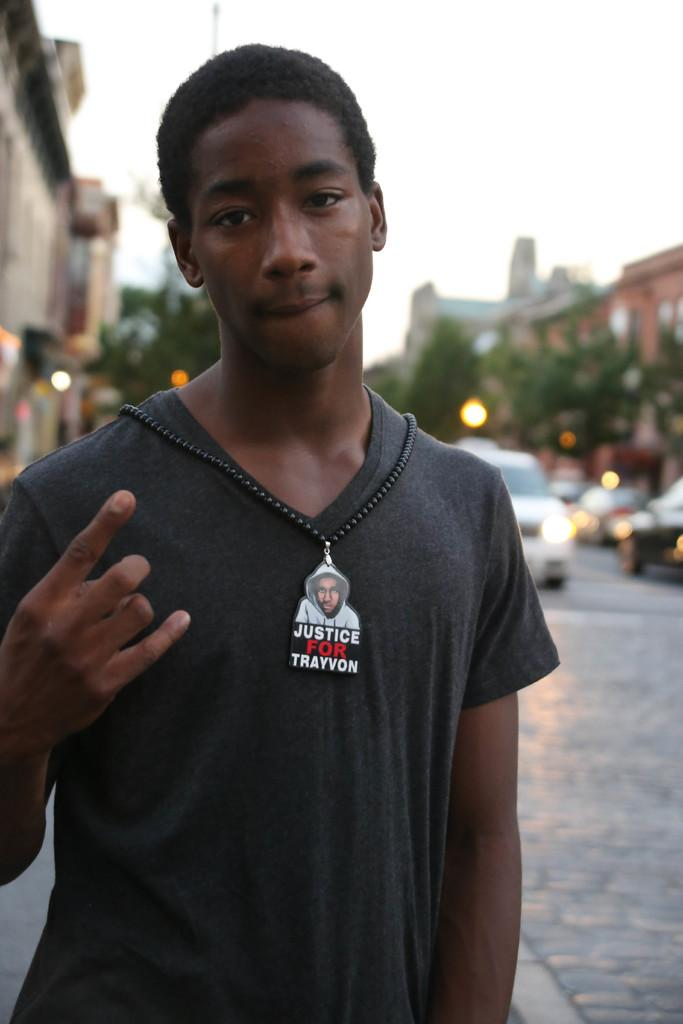What is the main subject of the image? There is a person standing in the center of the image. What is the person's position in relation to the ground? The person is standing on the ground. What can be seen in the background of the image? Cars, a road, trees, buildings, and the sky are visible in the background. How much sugar is the person holding in the image? There is no sugar visible in the image; the person is not holding anything. Can you see a hen in the image? No, there is no hen present in the image. 